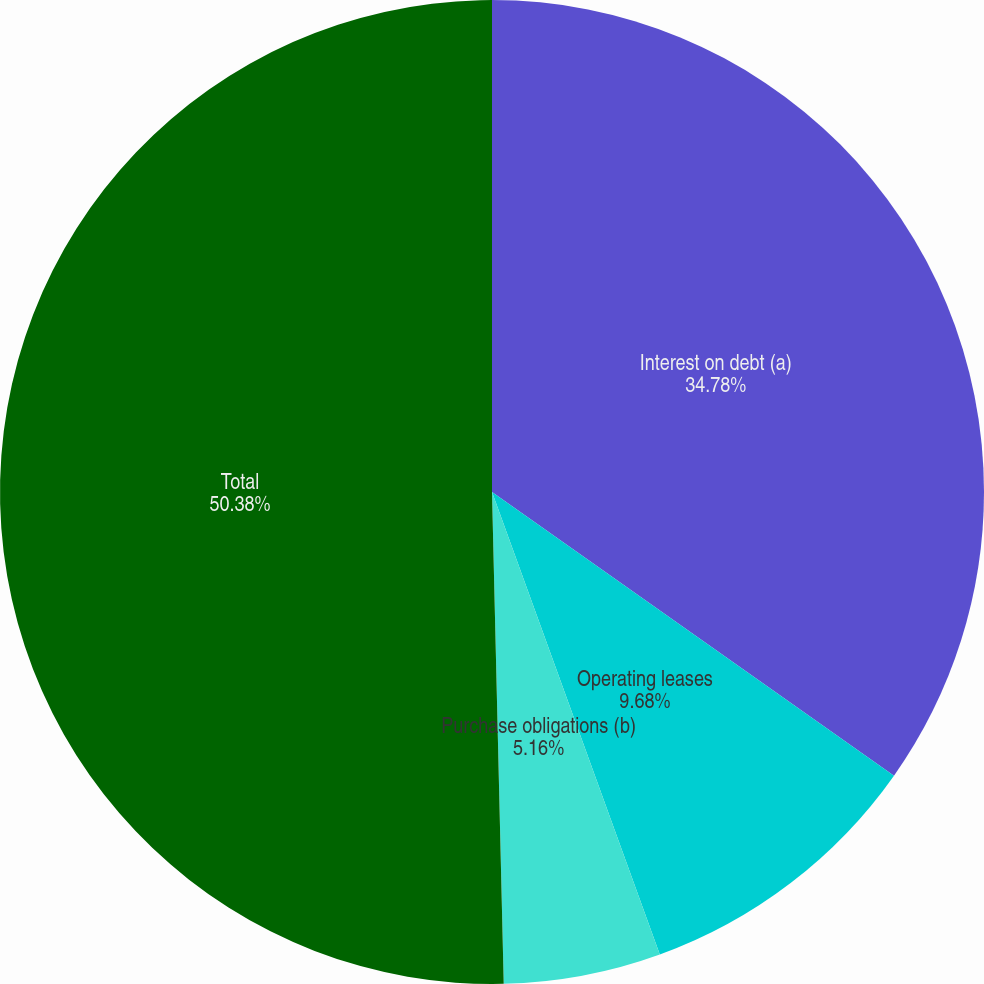Convert chart to OTSL. <chart><loc_0><loc_0><loc_500><loc_500><pie_chart><fcel>Interest on debt (a)<fcel>Operating leases<fcel>Purchase obligations (b)<fcel>Total<nl><fcel>34.78%<fcel>9.68%<fcel>5.16%<fcel>50.38%<nl></chart> 